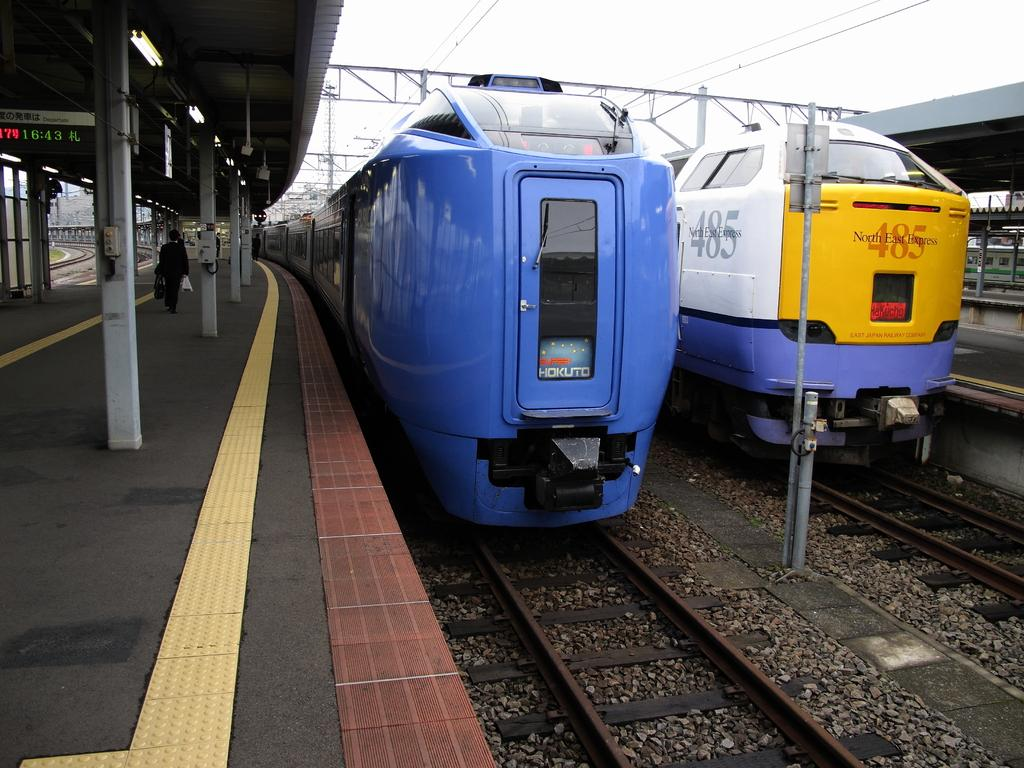<image>
Summarize the visual content of the image. Train engine 485 sits at a station waiting to leave. 